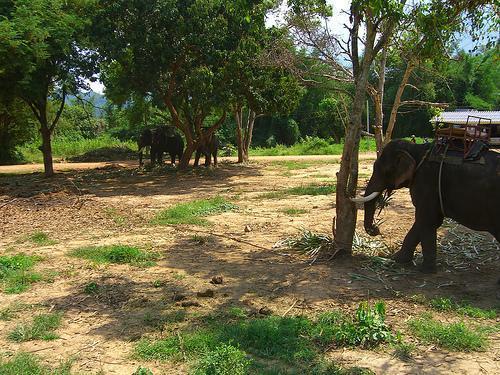How many elephants are in front of the close tree?
Give a very brief answer. 1. 